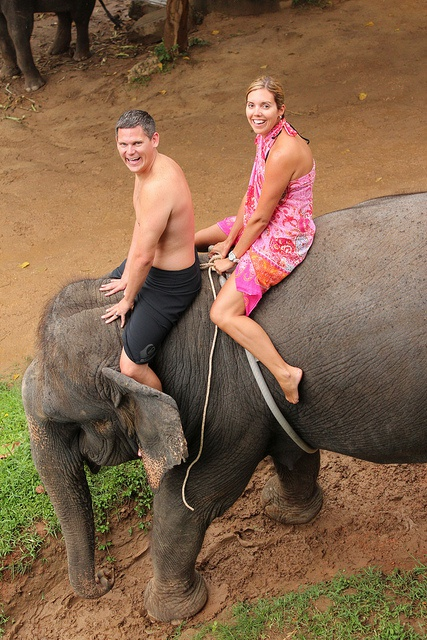Describe the objects in this image and their specific colors. I can see elephant in black and gray tones, people in black, salmon, and brown tones, people in black, tan, and salmon tones, and elephant in black, maroon, and gray tones in this image. 